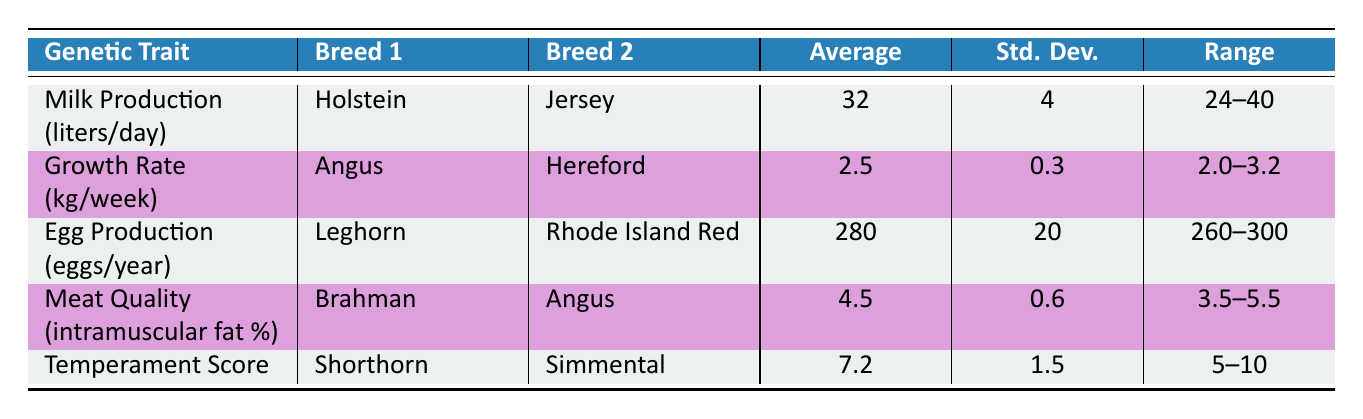What is the average milk production of Holstein-Jersey crossbred? The table indicates under the 'Average' column for 'Milk Production' that the value is 32 liters per day for the Holstein-Jersey crossbred.
Answer: 32 liters/day What is the range for egg production in Leghorn-Rhode Island Red crossbred? The range for egg production is listed in the table as 260 to 300 eggs per year under the 'Range' column for Leghorn-Rhode Island Red.
Answer: 260-300 eggs/year Do Brahman-Angus crossbreds have an average meat quality of more than 5 percent intramuscular fat? The table shows that the average for Brahman-Angus intramuscular fat percentage is 4.5, which is less than 5 percent. Therefore, the answer is no.
Answer: No Which crossbred has the highest average growth rate? Looking at the 'Average' column for 'Growth Rate', the Angus-Hereford crossbred has an average of 2.5 kg/week, which is higher than the other averages provided for different crossbreds.
Answer: Angus-Hereford If we combine the average milk production and egg production, what is the total? The average milk production for Holstein-Jersey is 32 liters/day and egg production for Leghorn-Rhode Island Red is 280 eggs/year. To find the total, we sum the two average values: 32 + 280 = 312.
Answer: 312 What is the standard deviation for temperament scores in the Shorthorn-Simmental crossbred? The standard deviation for the Shorthorn-Simmental crossbred under 'Std. Dev.' in the table is 1.5.
Answer: 1.5 Is the average growth rate for the Angus-Hereford crossbred greater than the average meat quality for Brahman-Angus crossbred? The average growth rate for Angus-Hereford is 2.5 kg/week and the average meat quality for Brahman-Angus is 4.5 percent. To compare, we look at kg/week versus percentage, which shows that these metrics cannot be directly compared; thus, the answer is no as they measure different traits.
Answer: No What is the lowest average value listed in the performance metrics? Scanning the 'Average' column, the lowest value is 2.5 for the Angus-Hereford growth rate, which is the minimum of all the averages provided.
Answer: 2.5 kg/week 